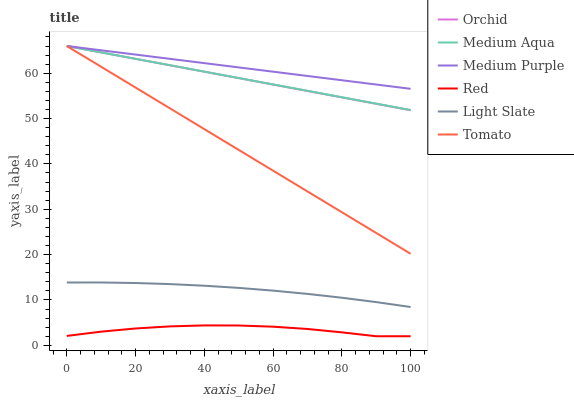Does Red have the minimum area under the curve?
Answer yes or no. Yes. Does Medium Purple have the maximum area under the curve?
Answer yes or no. Yes. Does Light Slate have the minimum area under the curve?
Answer yes or no. No. Does Light Slate have the maximum area under the curve?
Answer yes or no. No. Is Tomato the smoothest?
Answer yes or no. Yes. Is Red the roughest?
Answer yes or no. Yes. Is Light Slate the smoothest?
Answer yes or no. No. Is Light Slate the roughest?
Answer yes or no. No. Does Light Slate have the lowest value?
Answer yes or no. No. Does Orchid have the highest value?
Answer yes or no. Yes. Does Light Slate have the highest value?
Answer yes or no. No. Is Light Slate less than Medium Purple?
Answer yes or no. Yes. Is Light Slate greater than Red?
Answer yes or no. Yes. Does Light Slate intersect Medium Purple?
Answer yes or no. No. 